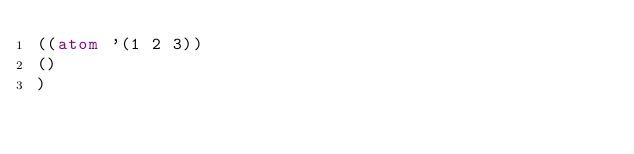Convert code to text. <code><loc_0><loc_0><loc_500><loc_500><_Lisp_>((atom '(1 2 3))
()
)
</code> 